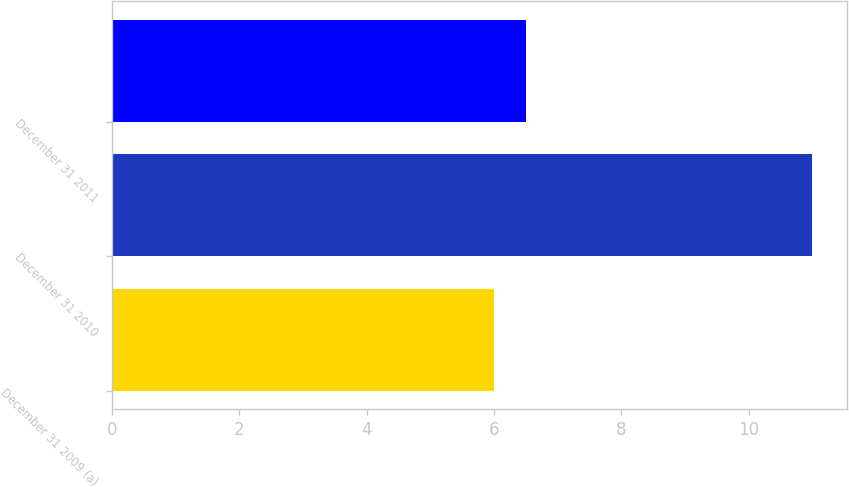Convert chart to OTSL. <chart><loc_0><loc_0><loc_500><loc_500><bar_chart><fcel>December 31 2009 (a)<fcel>December 31 2010<fcel>December 31 2011<nl><fcel>6<fcel>11<fcel>6.5<nl></chart> 